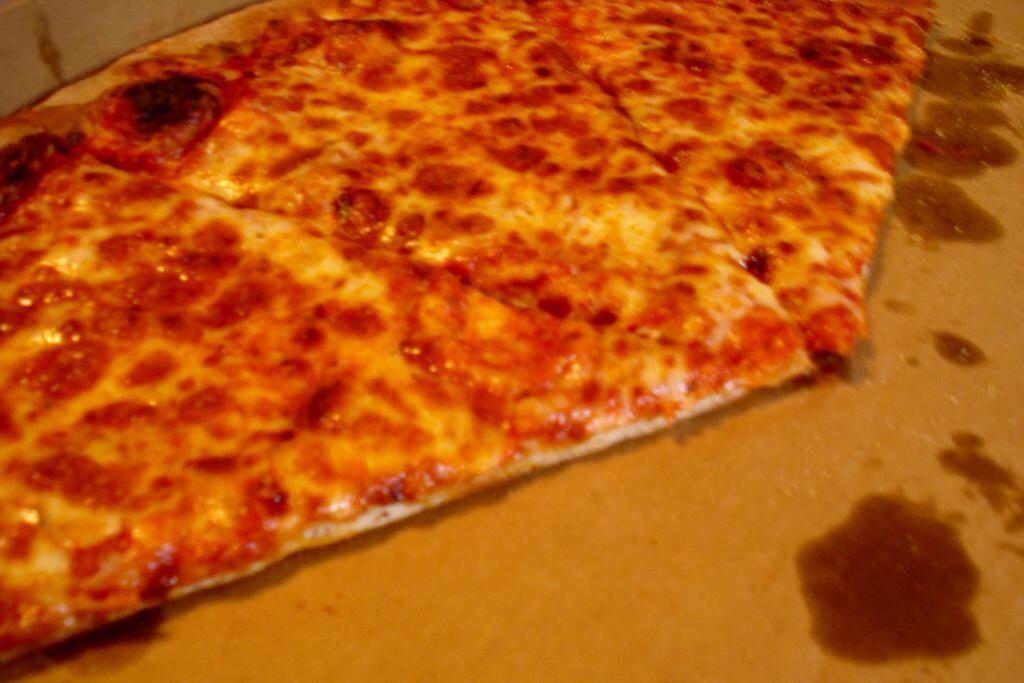How would you summarize this image in a sentence or two? In this image I can see the brown colored surface and on the surface I can see few pizza pieces which are cream, orange, black and red in color. 